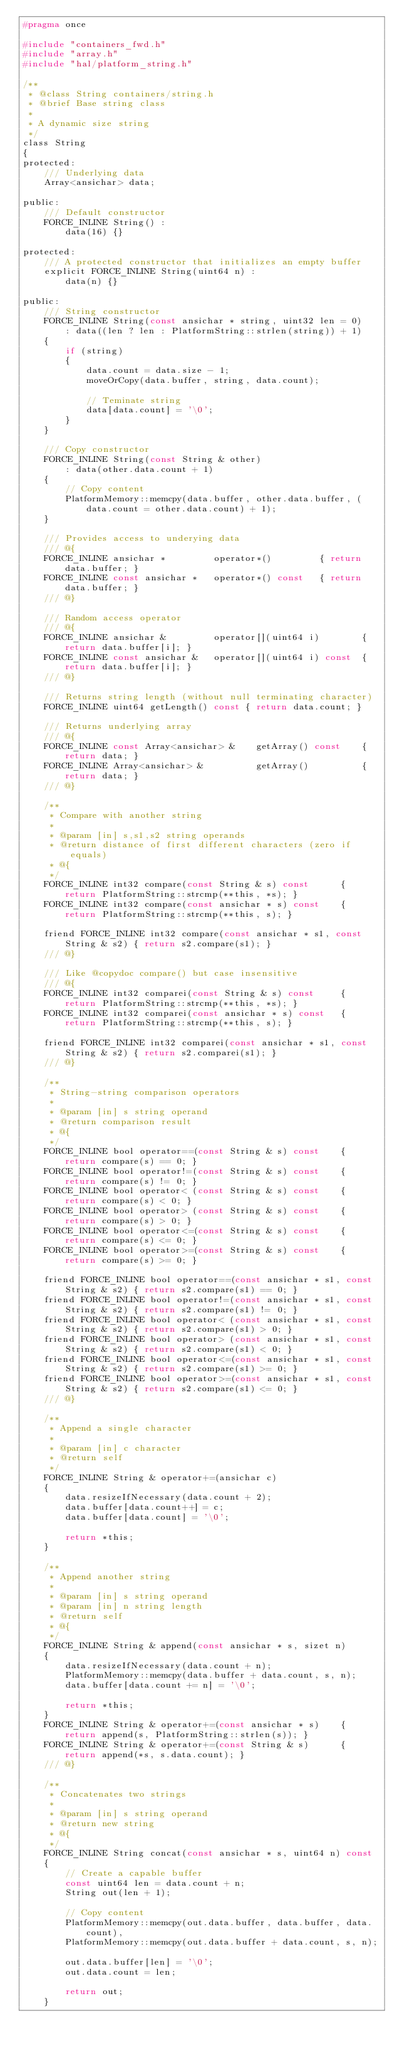Convert code to text. <code><loc_0><loc_0><loc_500><loc_500><_C_>#pragma once

#include "containers_fwd.h"
#include "array.h"
#include "hal/platform_string.h"

/**
 * @class String containers/string.h
 * @brief Base string class
 * 
 * A dynamic size string
 */
class String
{
protected:
	/// Underlying data
	Array<ansichar> data;

public:
	/// Default constructor
	FORCE_INLINE String() :
		data(16) {}
	
protected:
	/// A protected constructor that initializes an empty buffer
	explicit FORCE_INLINE String(uint64 n) :
		data(n) {}

public:
	/// String constructor
	FORCE_INLINE String(const ansichar * string, uint32 len = 0)
		: data((len ? len : PlatformString::strlen(string)) + 1)
	{
		if (string)
		{
			data.count = data.size - 1;
			moveOrCopy(data.buffer, string, data.count);

			// Teminate string
			data[data.count] = '\0';
		}
	}

	/// Copy constructor
	FORCE_INLINE String(const String & other)
		: data(other.data.count + 1)
	{
		// Copy content
		PlatformMemory::memcpy(data.buffer, other.data.buffer, (data.count = other.data.count) + 1);
	}

	/// Provides access to underying data
	/// @{
	FORCE_INLINE ansichar *			operator*()			{ return data.buffer; }
	FORCE_INLINE const ansichar *	operator*() const	{ return data.buffer; }
	/// @}

	/// Random access operator
	/// @{
	FORCE_INLINE ansichar &			operator[](uint64 i)		{ return data.buffer[i]; }
	FORCE_INLINE const ansichar &	operator[](uint64 i) const	{ return data.buffer[i]; }
	/// @}

	/// Returns string length (without null terminating character)
	FORCE_INLINE uint64 getLength() const { return data.count; }

	/// Returns underlying array
	/// @{
	FORCE_INLINE const Array<ansichar> &	getArray() const	{ return data; }
	FORCE_INLINE Array<ansichar> &			getArray()			{ return data; }
	/// @}

	/**
	 * Compare with another string
	 * 
	 * @param [in] s,s1,s2 string operands
	 * @return distance of first different characters (zero if equals)
	 * @{
	 */
	FORCE_INLINE int32 compare(const String & s) const		{ return PlatformString::strcmp(**this, *s); }
	FORCE_INLINE int32 compare(const ansichar * s) const	{ return PlatformString::strcmp(**this, s); }

	friend FORCE_INLINE int32 compare(const ansichar * s1, const String & s2) { return s2.compare(s1); }
	/// @}

	/// Like @copydoc compare() but case insensitive
	/// @{
	FORCE_INLINE int32 comparei(const String & s) const		{ return PlatformString::strcmp(**this, *s); }
	FORCE_INLINE int32 comparei(const ansichar * s) const	{ return PlatformString::strcmp(**this, s); }

	friend FORCE_INLINE int32 comparei(const ansichar * s1, const String & s2) { return s2.comparei(s1); }
	/// @}

	/**
	 * String-string comparison operators
	 * 
	 * @param [in] s string operand
	 * @return comparison result
	 * @{
	 */
	FORCE_INLINE bool operator==(const String & s) const	{ return compare(s) == 0; }
	FORCE_INLINE bool operator!=(const String & s) const	{ return compare(s) != 0; }
	FORCE_INLINE bool operator< (const String & s) const	{ return compare(s) < 0; }
	FORCE_INLINE bool operator> (const String & s) const	{ return compare(s) > 0; }
	FORCE_INLINE bool operator<=(const String & s) const	{ return compare(s) <= 0; }
	FORCE_INLINE bool operator>=(const String & s) const	{ return compare(s) >= 0; }

	friend FORCE_INLINE bool operator==(const ansichar * s1, const String & s2)	{ return s2.compare(s1) == 0; }
	friend FORCE_INLINE bool operator!=(const ansichar * s1, const String & s2)	{ return s2.compare(s1) != 0; }
	friend FORCE_INLINE bool operator< (const ansichar * s1, const String & s2) { return s2.compare(s1) > 0; }
	friend FORCE_INLINE bool operator> (const ansichar * s1, const String & s2) { return s2.compare(s1) < 0; }
	friend FORCE_INLINE bool operator<=(const ansichar * s1, const String & s2)	{ return s2.compare(s1) >= 0; }
	friend FORCE_INLINE bool operator>=(const ansichar * s1, const String & s2)	{ return s2.compare(s1) <= 0; }
	/// @}

	/**
	 * Append a single character
	 * 
	 * @param [in] c character
	 * @return self
	 */
	FORCE_INLINE String & operator+=(ansichar c)
	{
		data.resizeIfNecessary(data.count + 2);
		data.buffer[data.count++] = c;
		data.buffer[data.count] = '\0';

		return *this;
	}

	/**
	 * Append another string
	 * 
	 * @param [in] s string operand
	 * @param [in] n string length
	 * @return self
	 * @{
	 */
	FORCE_INLINE String & append(const ansichar * s, sizet n)
	{
		data.resizeIfNecessary(data.count + n);
		PlatformMemory::memcpy(data.buffer + data.count, s, n);
		data.buffer[data.count += n] = '\0';

		return *this;
	}
	FORCE_INLINE String & operator+=(const ansichar * s)	{ return append(s, PlatformString::strlen(s)); }
	FORCE_INLINE String & operator+=(const String & s)		{ return append(*s, s.data.count); }
	/// @}

	/**
	 * Concatenates two strings
	 * 
	 * @param [in] s string operand
	 * @return new string
	 * @{
	 */
	FORCE_INLINE String concat(const ansichar * s, uint64 n) const
	{
		// Create a capable buffer
		const uint64 len = data.count + n;
		String out(len + 1);

		// Copy content
		PlatformMemory::memcpy(out.data.buffer, data.buffer, data.count),
		PlatformMemory::memcpy(out.data.buffer + data.count, s, n);

		out.data.buffer[len] = '\0';
		out.data.count = len;

		return out;
	}</code> 